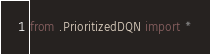Convert code to text. <code><loc_0><loc_0><loc_500><loc_500><_Python_>from .PrioritizedDQN import *</code> 